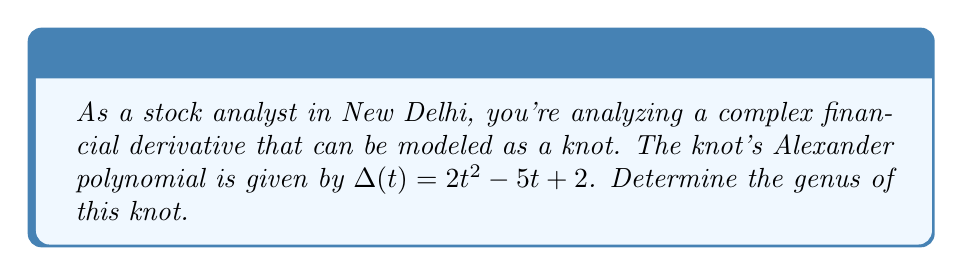Solve this math problem. To determine the genus of a knot using its Alexander polynomial, we can follow these steps:

1. Recall that for any knot $K$, the degree of its Alexander polynomial $\Delta_K(t)$ is always even and is bounded above by twice the genus of the knot:

   $$\deg(\Delta_K(t)) \leq 2g(K)$$

   where $g(K)$ is the genus of the knot.

2. In this case, the Alexander polynomial is $\Delta(t) = 2t^2 - 5t + 2$.

3. Determine the degree of the polynomial:
   The highest power of $t$ is 2, so $\deg(\Delta(t)) = 2$.

4. Apply the inequality:
   $$2 \leq 2g(K)$$

5. Solve for $g(K)$:
   $$g(K) \geq 1$$

6. Since the genus must be a non-negative integer, and it's bounded below by 1, we can conclude that the minimum possible genus is 1.

7. Note: The Alexander polynomial doesn't always determine the exact genus, but gives a lower bound. In this case, the knot has a genus of at least 1.
Answer: 1 